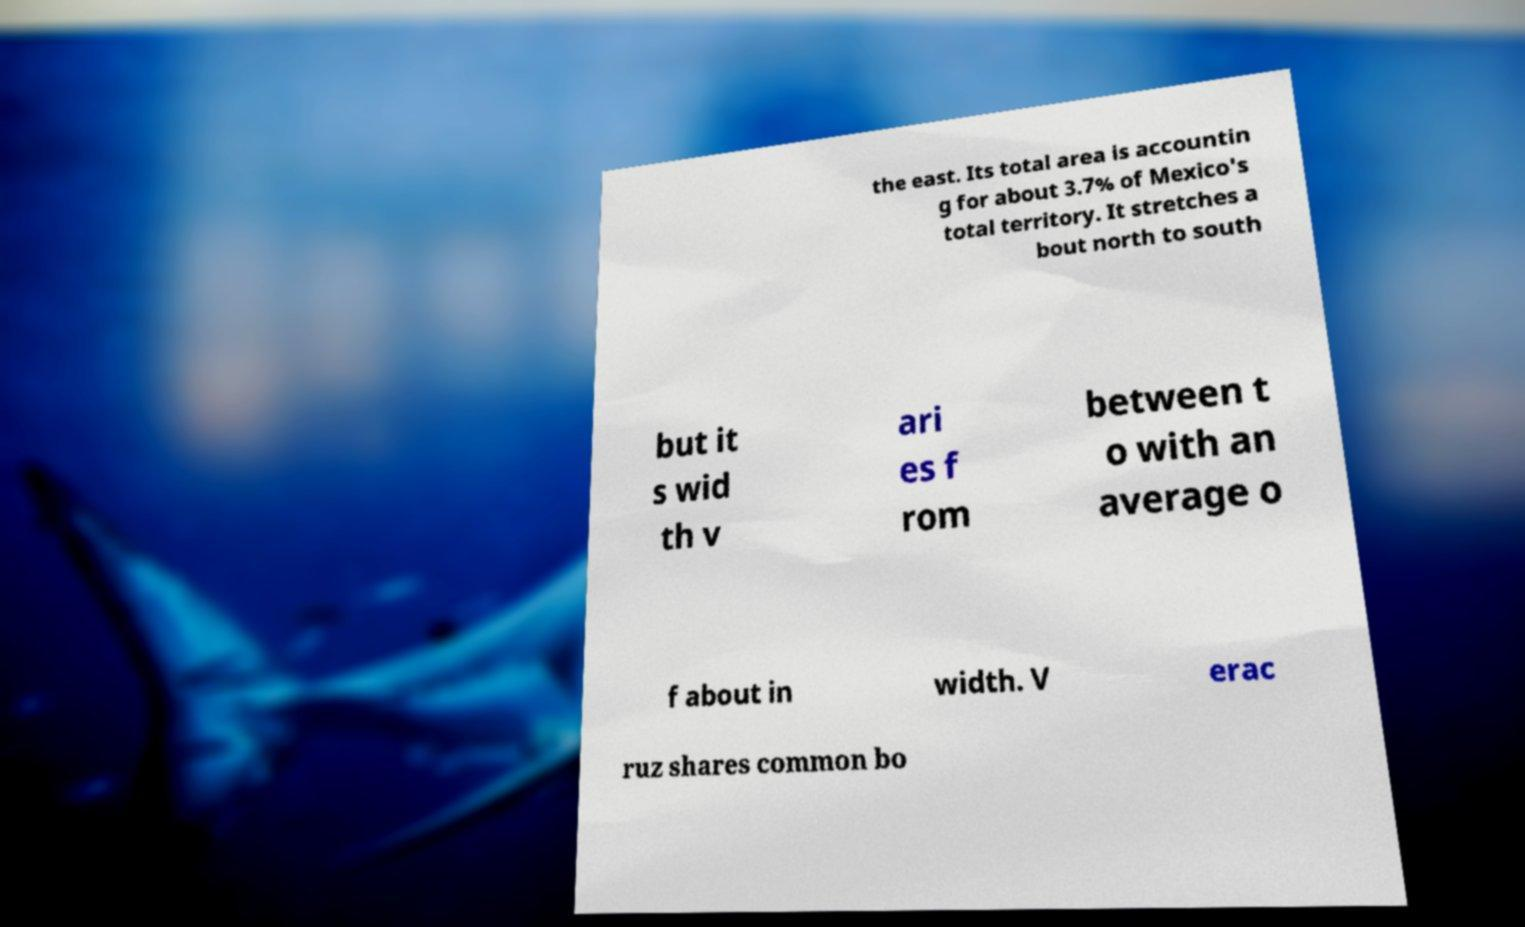There's text embedded in this image that I need extracted. Can you transcribe it verbatim? the east. Its total area is accountin g for about 3.7% of Mexico's total territory. It stretches a bout north to south but it s wid th v ari es f rom between t o with an average o f about in width. V erac ruz shares common bo 